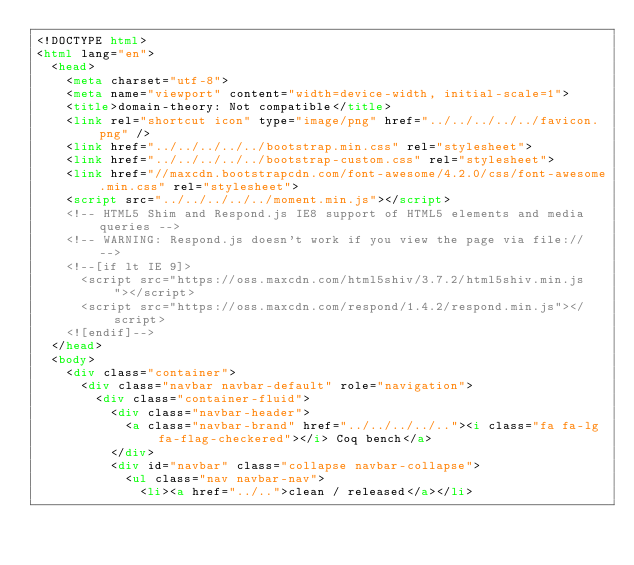<code> <loc_0><loc_0><loc_500><loc_500><_HTML_><!DOCTYPE html>
<html lang="en">
  <head>
    <meta charset="utf-8">
    <meta name="viewport" content="width=device-width, initial-scale=1">
    <title>domain-theory: Not compatible</title>
    <link rel="shortcut icon" type="image/png" href="../../../../../favicon.png" />
    <link href="../../../../../bootstrap.min.css" rel="stylesheet">
    <link href="../../../../../bootstrap-custom.css" rel="stylesheet">
    <link href="//maxcdn.bootstrapcdn.com/font-awesome/4.2.0/css/font-awesome.min.css" rel="stylesheet">
    <script src="../../../../../moment.min.js"></script>
    <!-- HTML5 Shim and Respond.js IE8 support of HTML5 elements and media queries -->
    <!-- WARNING: Respond.js doesn't work if you view the page via file:// -->
    <!--[if lt IE 9]>
      <script src="https://oss.maxcdn.com/html5shiv/3.7.2/html5shiv.min.js"></script>
      <script src="https://oss.maxcdn.com/respond/1.4.2/respond.min.js"></script>
    <![endif]-->
  </head>
  <body>
    <div class="container">
      <div class="navbar navbar-default" role="navigation">
        <div class="container-fluid">
          <div class="navbar-header">
            <a class="navbar-brand" href="../../../../.."><i class="fa fa-lg fa-flag-checkered"></i> Coq bench</a>
          </div>
          <div id="navbar" class="collapse navbar-collapse">
            <ul class="nav navbar-nav">
              <li><a href="../..">clean / released</a></li></code> 